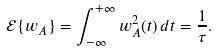<formula> <loc_0><loc_0><loc_500><loc_500>\mathcal { E } \{ w _ { A } \} & = \int _ { - \infty } ^ { + \infty } w ^ { 2 } _ { A } ( t ) \, d t = \frac { 1 } { \tau } .</formula> 